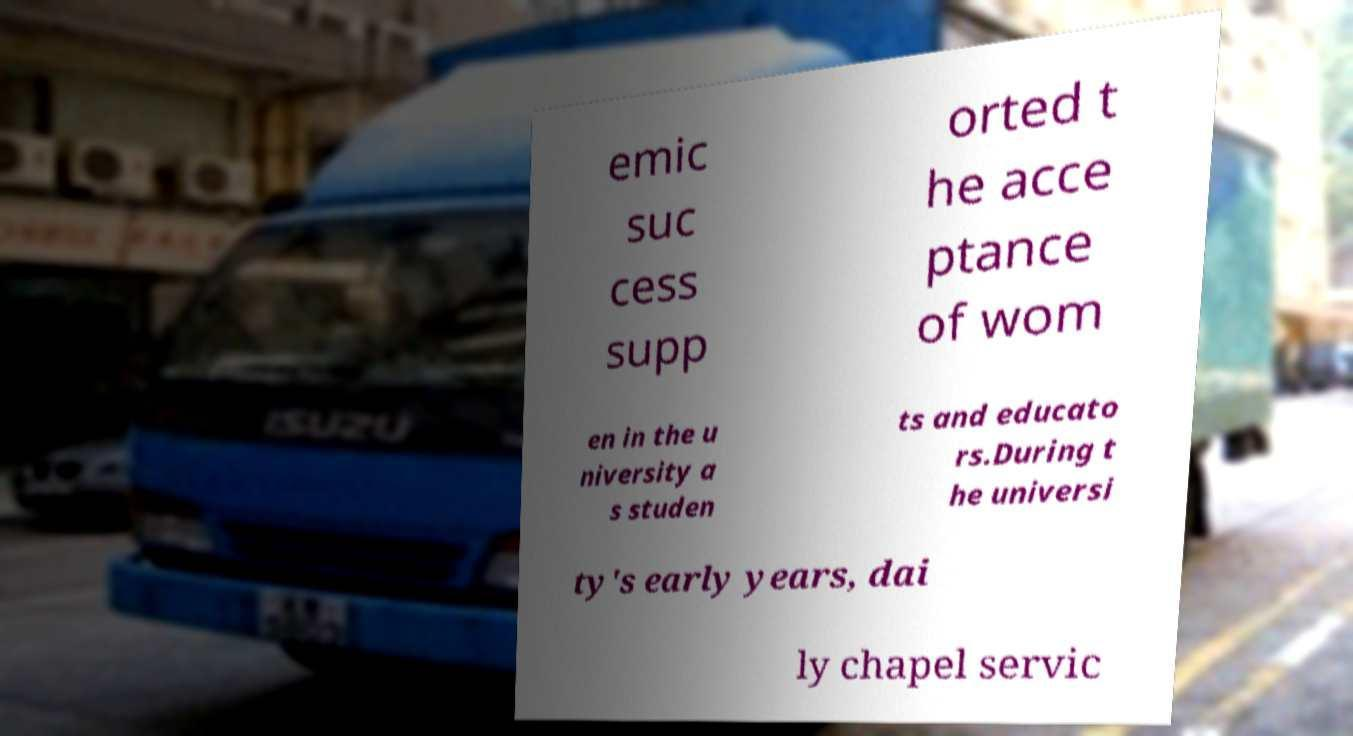Can you read and provide the text displayed in the image?This photo seems to have some interesting text. Can you extract and type it out for me? emic suc cess supp orted t he acce ptance of wom en in the u niversity a s studen ts and educato rs.During t he universi ty's early years, dai ly chapel servic 